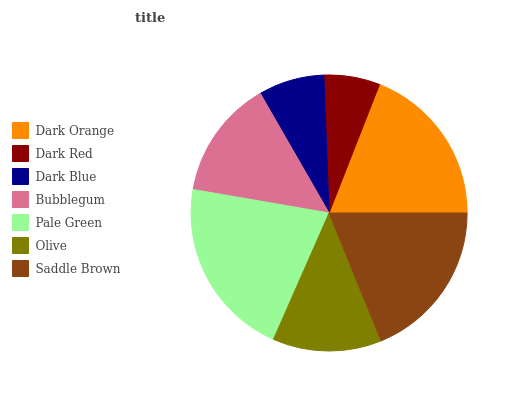Is Dark Red the minimum?
Answer yes or no. Yes. Is Pale Green the maximum?
Answer yes or no. Yes. Is Dark Blue the minimum?
Answer yes or no. No. Is Dark Blue the maximum?
Answer yes or no. No. Is Dark Blue greater than Dark Red?
Answer yes or no. Yes. Is Dark Red less than Dark Blue?
Answer yes or no. Yes. Is Dark Red greater than Dark Blue?
Answer yes or no. No. Is Dark Blue less than Dark Red?
Answer yes or no. No. Is Bubblegum the high median?
Answer yes or no. Yes. Is Bubblegum the low median?
Answer yes or no. Yes. Is Dark Blue the high median?
Answer yes or no. No. Is Dark Orange the low median?
Answer yes or no. No. 